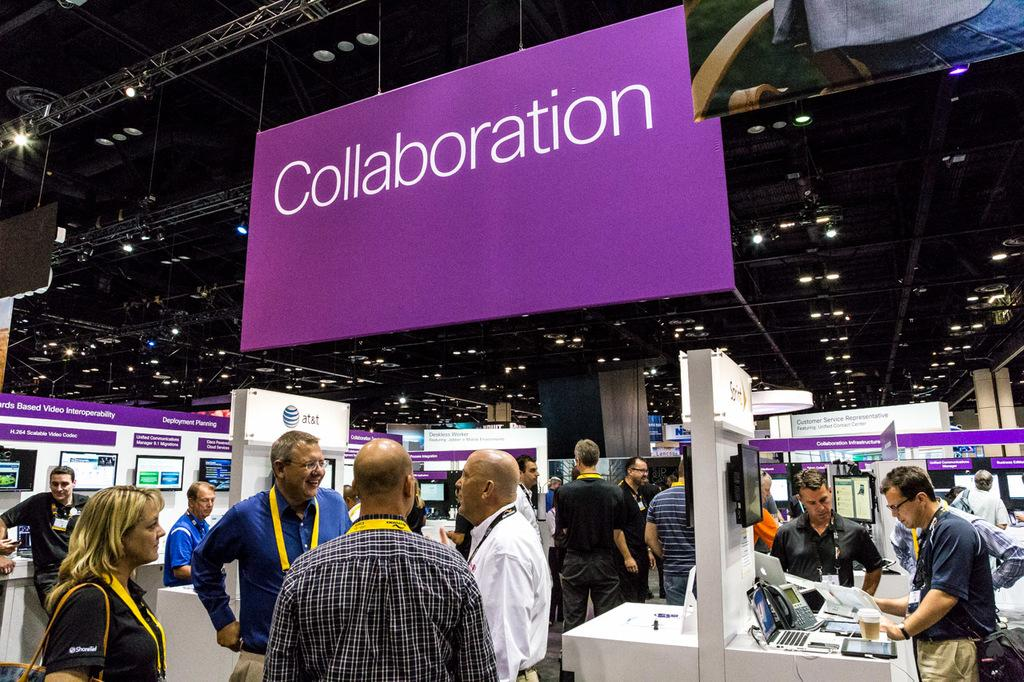<image>
Write a terse but informative summary of the picture. Giant purple Collaboration sign hanging in a convention. 